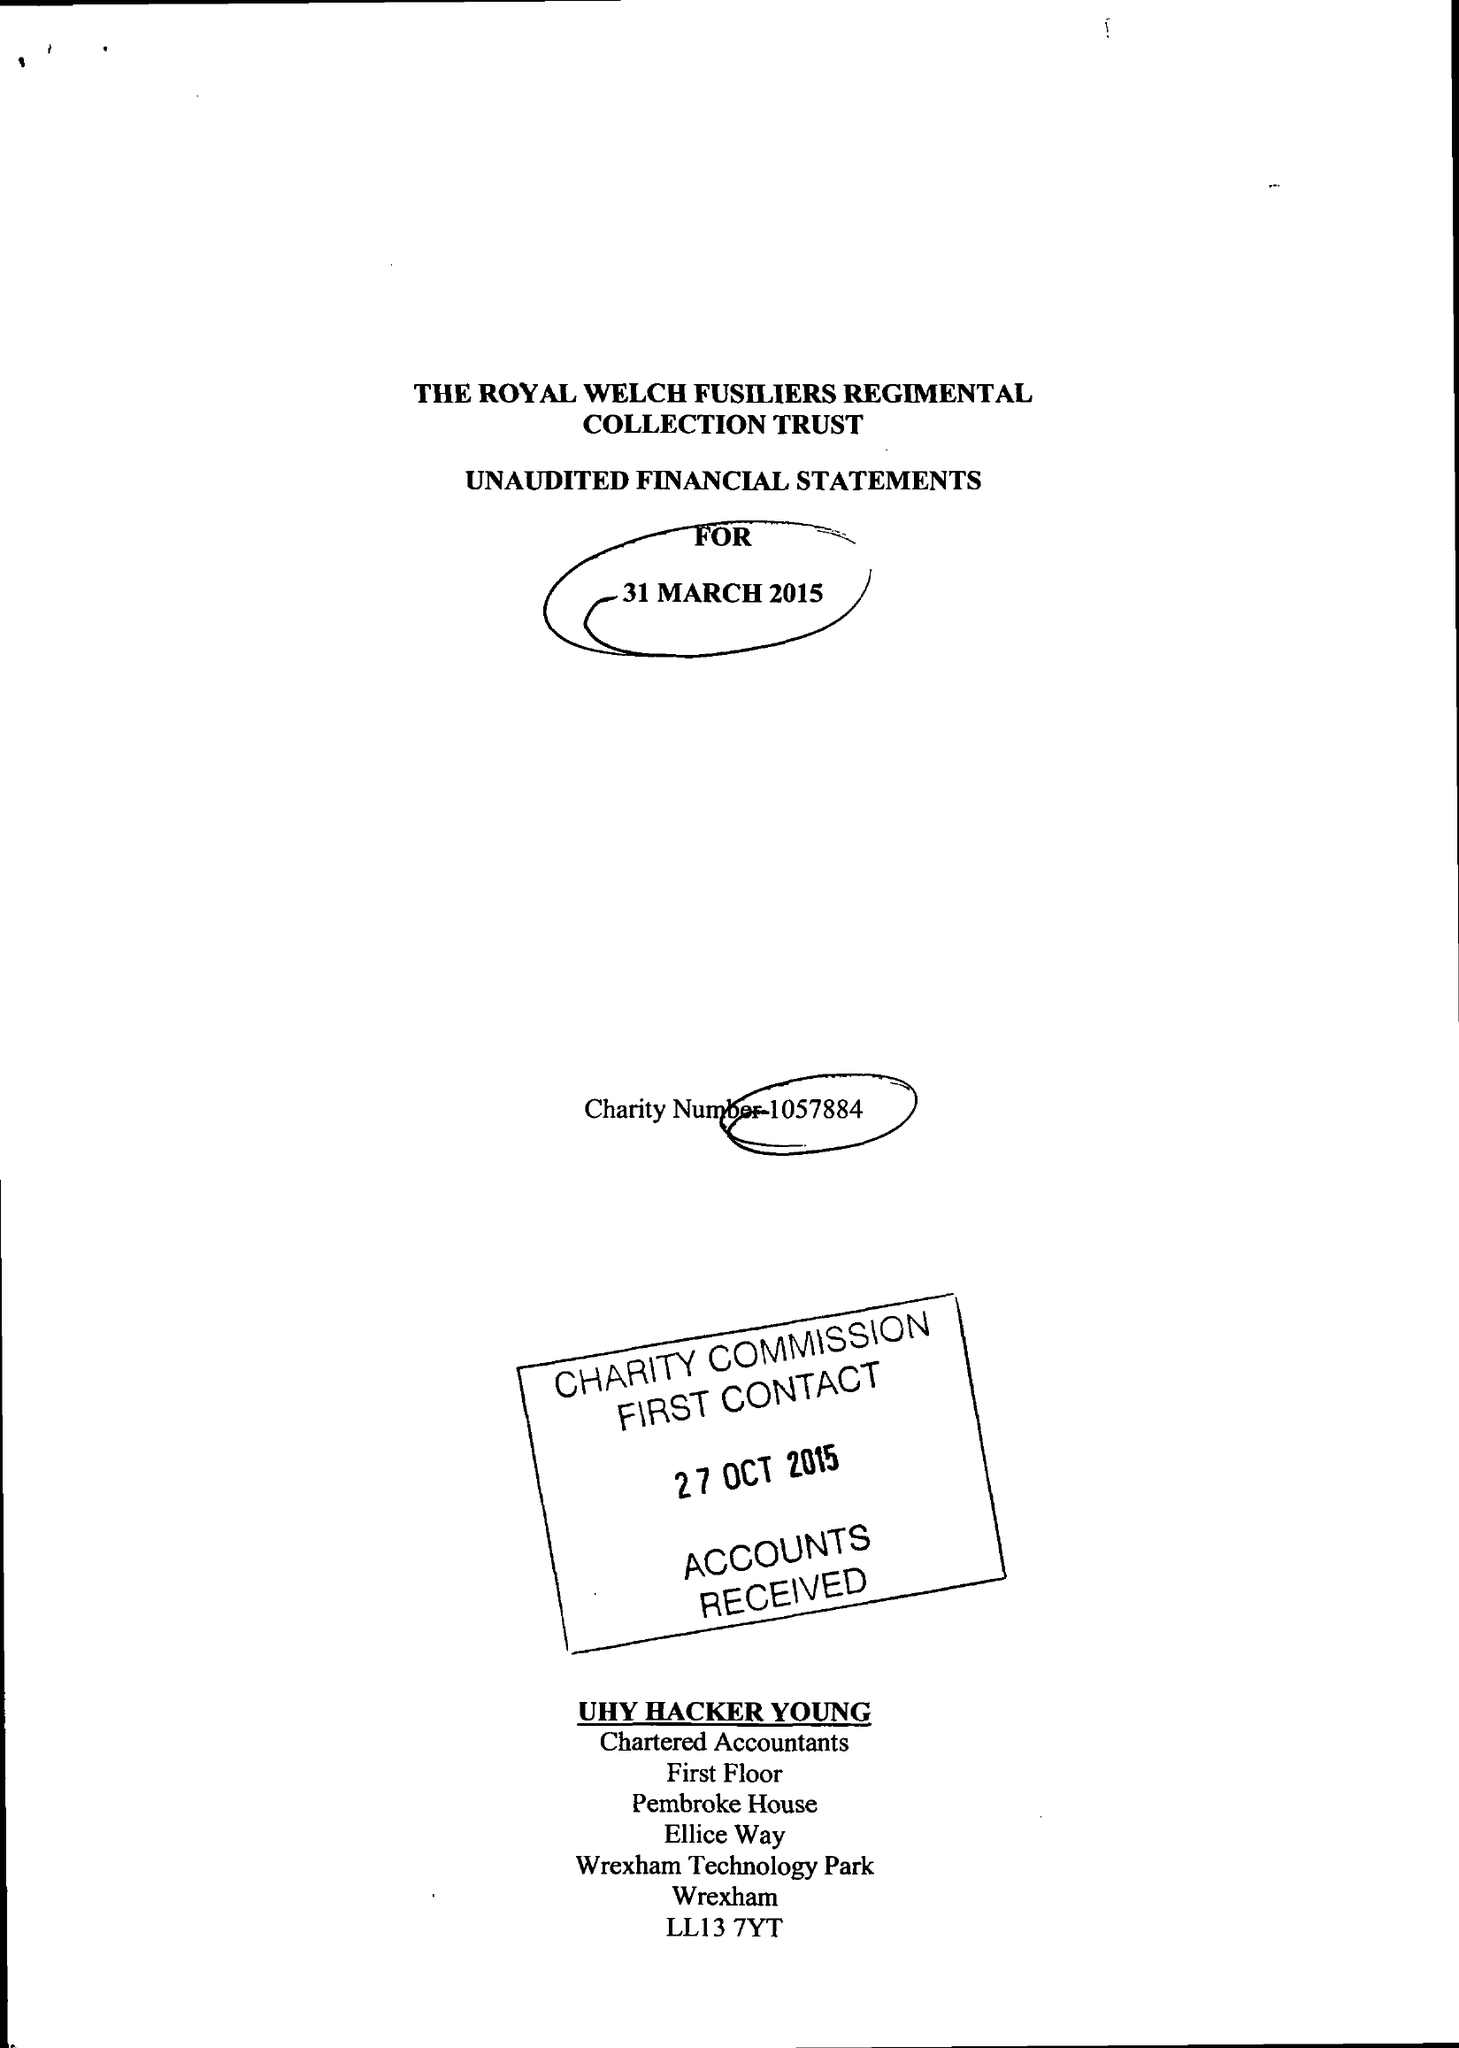What is the value for the spending_annually_in_british_pounds?
Answer the question using a single word or phrase. 181950.00 